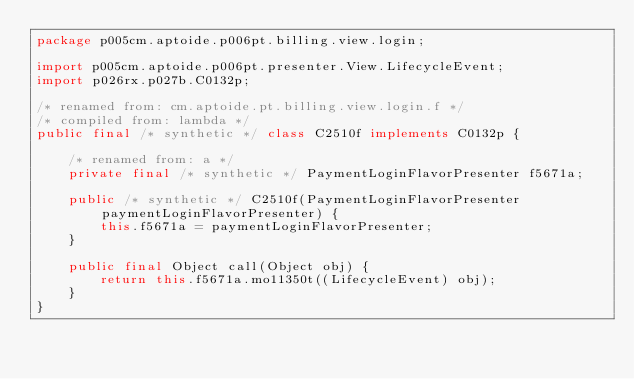<code> <loc_0><loc_0><loc_500><loc_500><_Java_>package p005cm.aptoide.p006pt.billing.view.login;

import p005cm.aptoide.p006pt.presenter.View.LifecycleEvent;
import p026rx.p027b.C0132p;

/* renamed from: cm.aptoide.pt.billing.view.login.f */
/* compiled from: lambda */
public final /* synthetic */ class C2510f implements C0132p {

    /* renamed from: a */
    private final /* synthetic */ PaymentLoginFlavorPresenter f5671a;

    public /* synthetic */ C2510f(PaymentLoginFlavorPresenter paymentLoginFlavorPresenter) {
        this.f5671a = paymentLoginFlavorPresenter;
    }

    public final Object call(Object obj) {
        return this.f5671a.mo11350t((LifecycleEvent) obj);
    }
}
</code> 